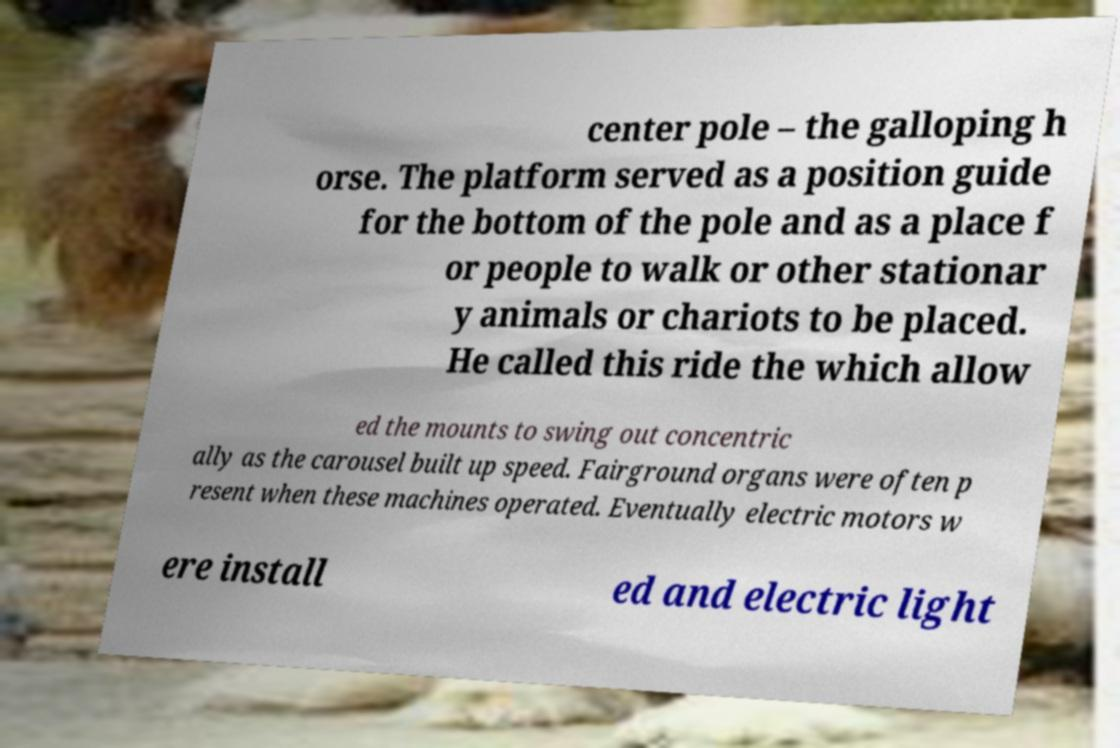Please identify and transcribe the text found in this image. center pole – the galloping h orse. The platform served as a position guide for the bottom of the pole and as a place f or people to walk or other stationar y animals or chariots to be placed. He called this ride the which allow ed the mounts to swing out concentric ally as the carousel built up speed. Fairground organs were often p resent when these machines operated. Eventually electric motors w ere install ed and electric light 